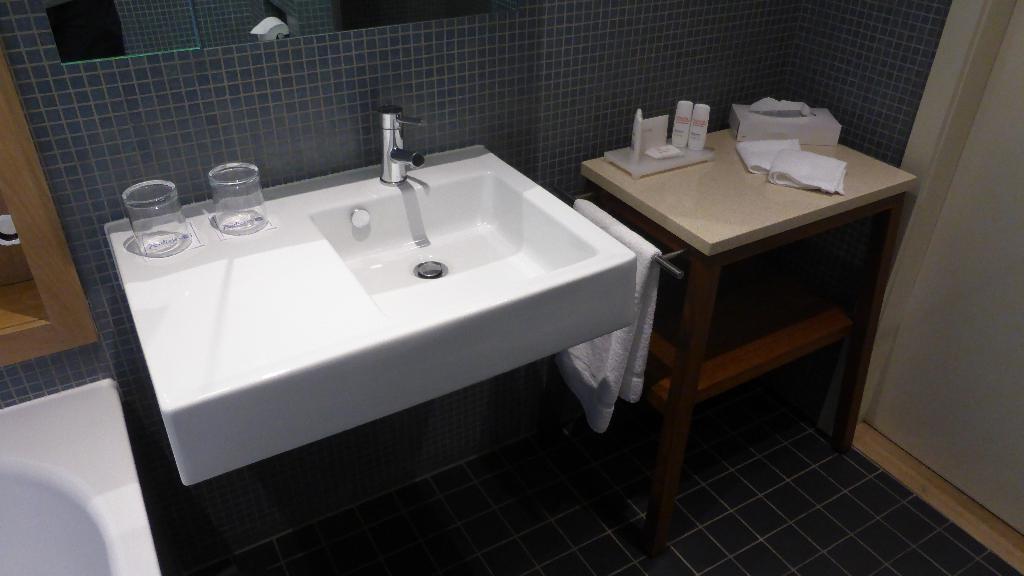In one or two sentences, can you explain what this image depicts? In this picture we can see a table on the floor, beside this table we can see sinks, tap, here we can see a cloth, tissue papers, glasses and some objects and in the background we can see a door, wall, mirrors. 